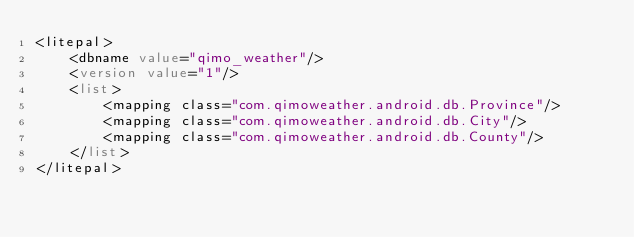Convert code to text. <code><loc_0><loc_0><loc_500><loc_500><_XML_><litepal>
    <dbname value="qimo_weather"/>
    <version value="1"/>
    <list>
        <mapping class="com.qimoweather.android.db.Province"/>
        <mapping class="com.qimoweather.android.db.City"/>
        <mapping class="com.qimoweather.android.db.County"/>
    </list>
</litepal></code> 